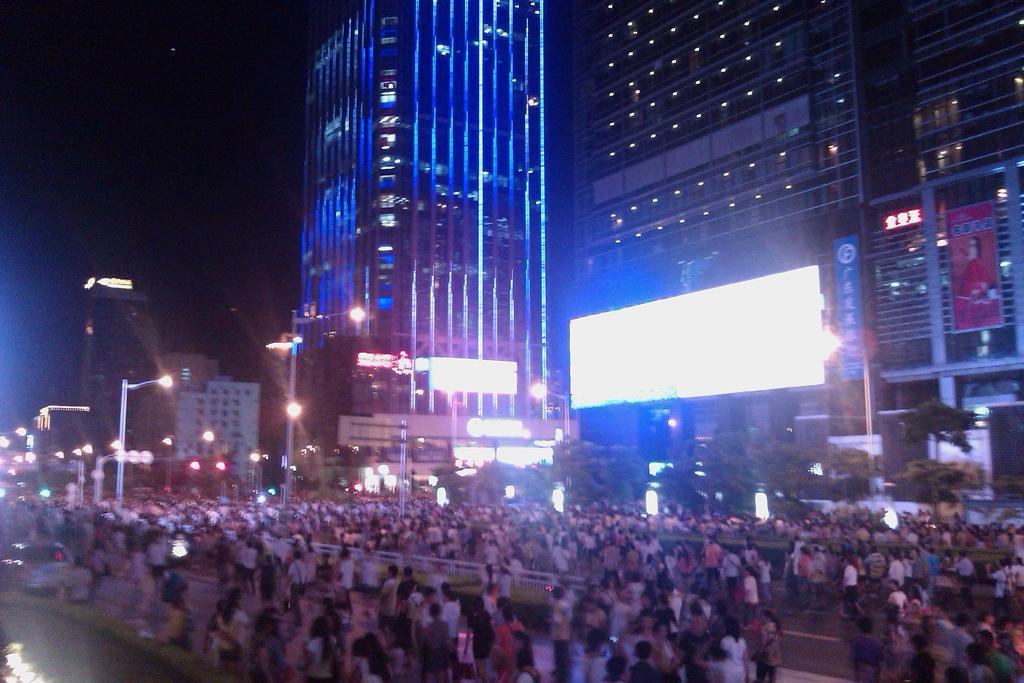How would you summarize this image in a sentence or two? In this picture we can see a group of people on the roads, poles, lights, buildings and in the background it is dark. 